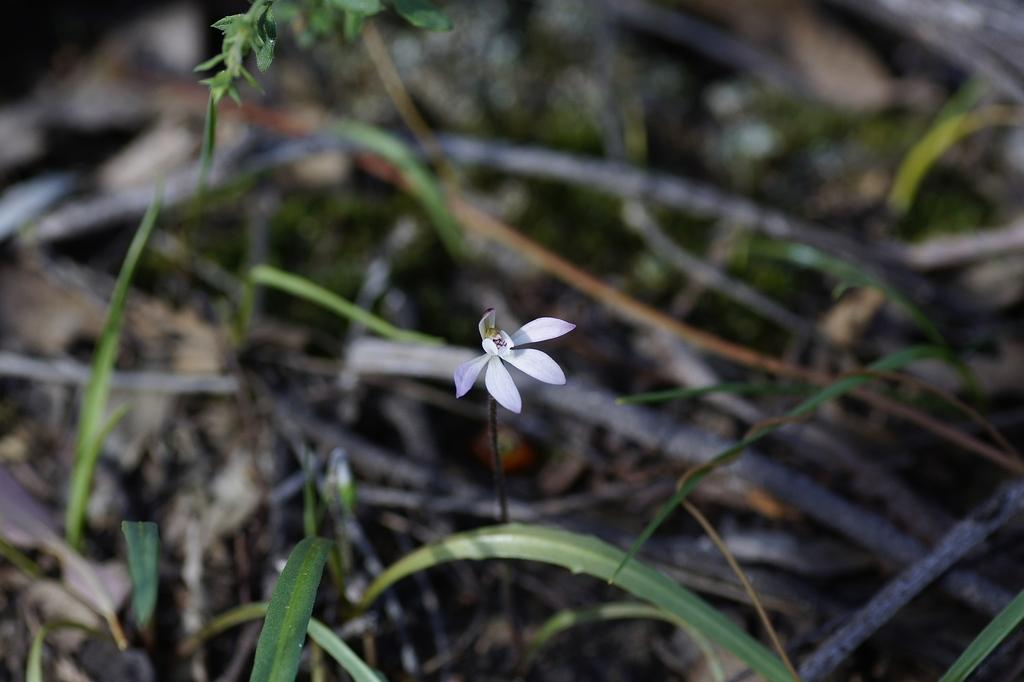What is the main subject in the middle of the image? There is a flower in the middle of the image. What type of vegetation is at the bottom of the image? There is grass at the bottom of the image. What other type of plant is visible in the image? There is a plant at the top of the image. How would you describe the background of the image? The background of the image appears blurry. How many girls are present in the image? There are no girls present in the image; it features a flower, grass, and another plant. What time of day is depicted in the image? The time of day cannot be determined from the image, as it only features plants and vegetation. 